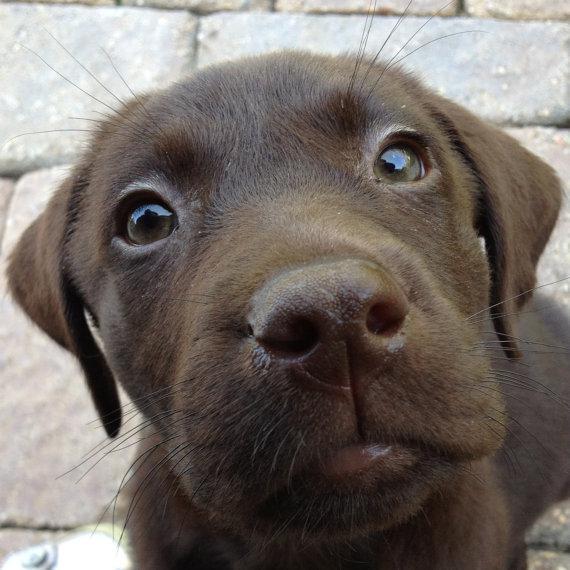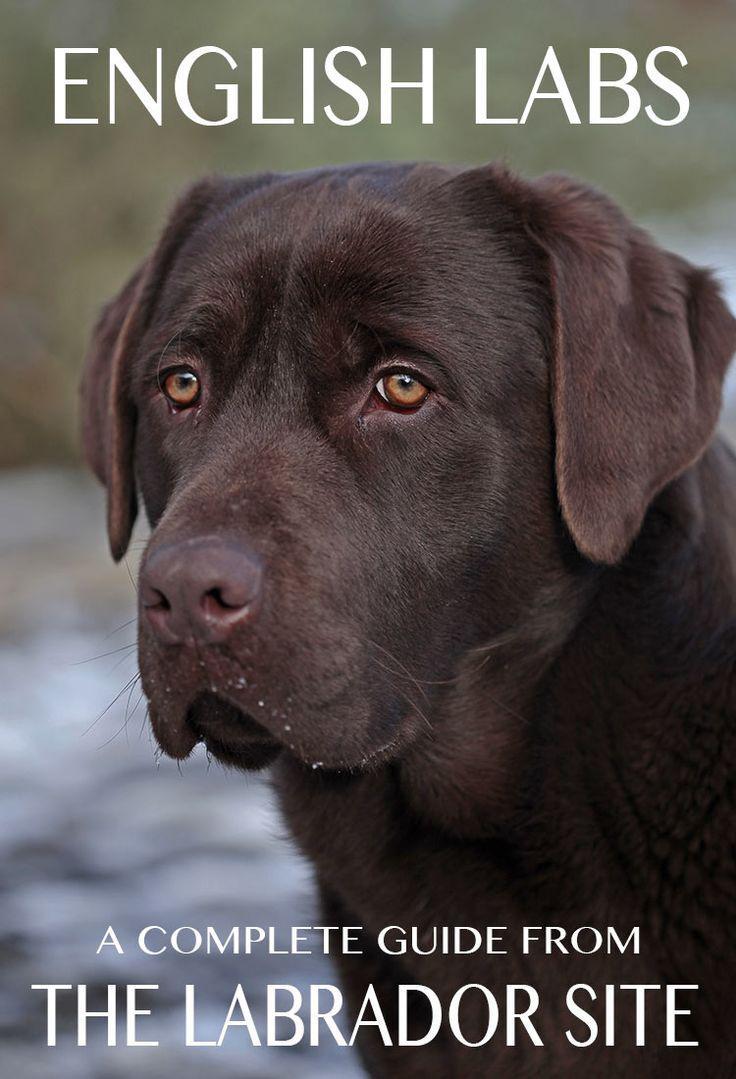The first image is the image on the left, the second image is the image on the right. For the images shown, is this caption "One of the images shows a dog with its tongue sticking out." true? Answer yes or no. No. The first image is the image on the left, the second image is the image on the right. Evaluate the accuracy of this statement regarding the images: "Both images are a head shot of one dog with its mouth closed.". Is it true? Answer yes or no. Yes. 